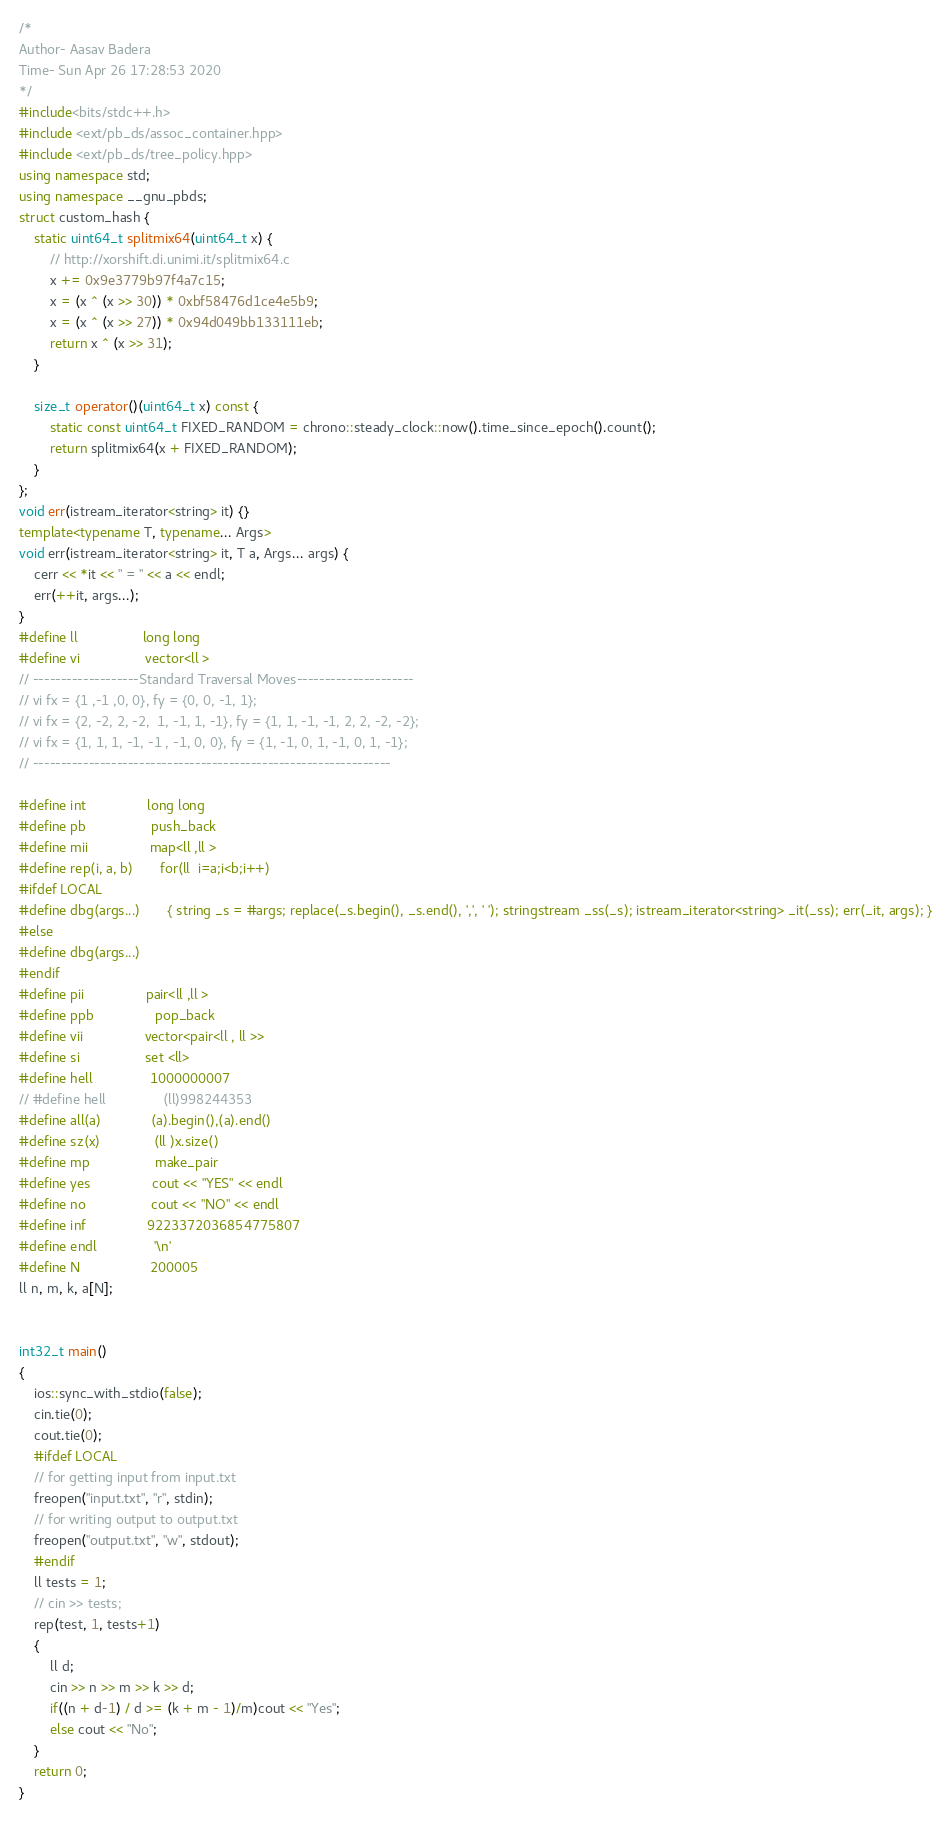<code> <loc_0><loc_0><loc_500><loc_500><_C++_>/*
Author- Aasav Badera
Time- Sun Apr 26 17:28:53 2020
*/
#include<bits/stdc++.h> 
#include <ext/pb_ds/assoc_container.hpp>
#include <ext/pb_ds/tree_policy.hpp> 
using namespace std;
using namespace __gnu_pbds;
struct custom_hash {
    static uint64_t splitmix64(uint64_t x) {
        // http://xorshift.di.unimi.it/splitmix64.c
        x += 0x9e3779b97f4a7c15;
        x = (x ^ (x >> 30)) * 0xbf58476d1ce4e5b9;
        x = (x ^ (x >> 27)) * 0x94d049bb133111eb;
        return x ^ (x >> 31);
    }

    size_t operator()(uint64_t x) const {
        static const uint64_t FIXED_RANDOM = chrono::steady_clock::now().time_since_epoch().count();
        return splitmix64(x + FIXED_RANDOM);
    }
};
void err(istream_iterator<string> it) {}
template<typename T, typename... Args>
void err(istream_iterator<string> it, T a, Args... args) {
    cerr << *it << " = " << a << endl;
    err(++it, args...);
}
#define ll                 long long    
#define vi                 vector<ll >
// -------------------Standard Traversal Moves---------------------
// vi fx = {1 ,-1 ,0, 0}, fy = {0, 0, -1, 1};
// vi fx = {2, -2, 2, -2,  1, -1, 1, -1}, fy = {1, 1, -1, -1, 2, 2, -2, -2};
// vi fx = {1, 1, 1, -1, -1 , -1, 0, 0}, fy = {1, -1, 0, 1, -1, 0, 1, -1};
// ----------------------------------------------------------------

#define int                long long                        
#define pb                 push_back                                                     
#define mii                map<ll ,ll >
#define rep(i, a, b)       for(ll  i=a;i<b;i++)
#ifdef LOCAL
#define dbg(args...)       { string _s = #args; replace(_s.begin(), _s.end(), ',', ' '); stringstream _ss(_s); istream_iterator<string> _it(_ss); err(_it, args); }
#else
#define dbg(args...)
#endif
#define pii                pair<ll ,ll >
#define ppb                pop_back
#define vii                vector<pair<ll , ll >>
#define si                 set <ll>
#define hell               1000000007
// #define hell               (ll)998244353
#define all(a)             (a).begin(),(a).end()
#define sz(x)              (ll )x.size()
#define mp                 make_pair
#define yes                cout << "YES" << endl
#define no                 cout << "NO" << endl
#define inf                9223372036854775807
#define endl               '\n' 
#define N                  200005
ll n, m, k, a[N];


int32_t main()
{
    ios::sync_with_stdio(false);
    cin.tie(0);
    cout.tie(0);
    #ifdef LOCAL
    // for getting input from input.txt
    freopen("input.txt", "r", stdin);
    // for writing output to output.txt
    freopen("output.txt", "w", stdout);
    #endif
    ll tests = 1;
    // cin >> tests;
    rep(test, 1, tests+1)
    {
    	ll d;
        cin >> n >> m >> k >> d;
        if((n + d-1) / d >= (k + m - 1)/m)cout << "Yes";
        else cout << "No";
    }
    return 0;
}</code> 